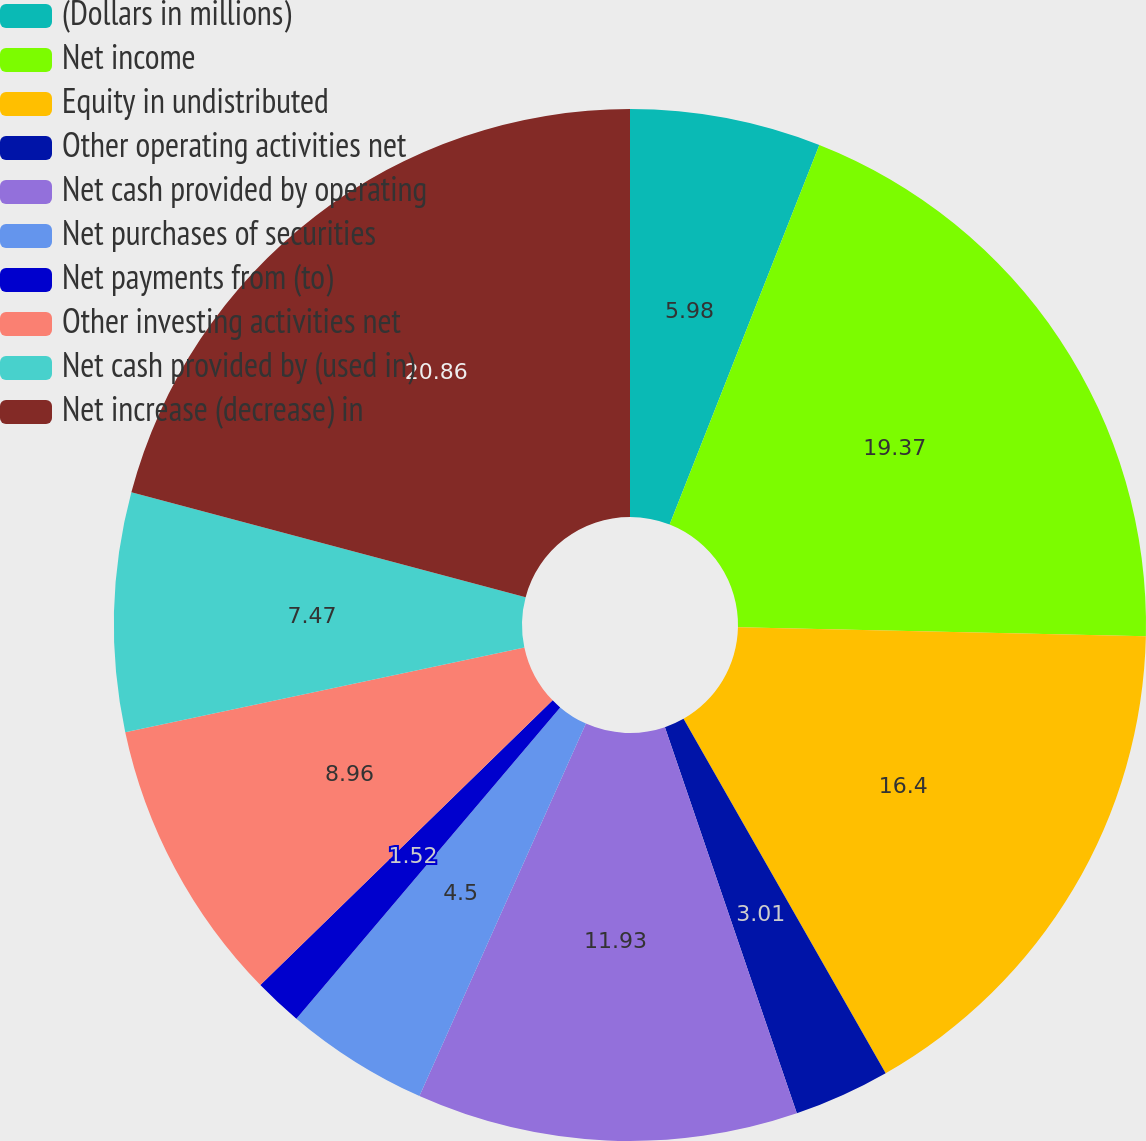<chart> <loc_0><loc_0><loc_500><loc_500><pie_chart><fcel>(Dollars in millions)<fcel>Net income<fcel>Equity in undistributed<fcel>Other operating activities net<fcel>Net cash provided by operating<fcel>Net purchases of securities<fcel>Net payments from (to)<fcel>Other investing activities net<fcel>Net cash provided by (used in)<fcel>Net increase (decrease) in<nl><fcel>5.98%<fcel>19.37%<fcel>16.4%<fcel>3.01%<fcel>11.93%<fcel>4.5%<fcel>1.52%<fcel>8.96%<fcel>7.47%<fcel>20.86%<nl></chart> 